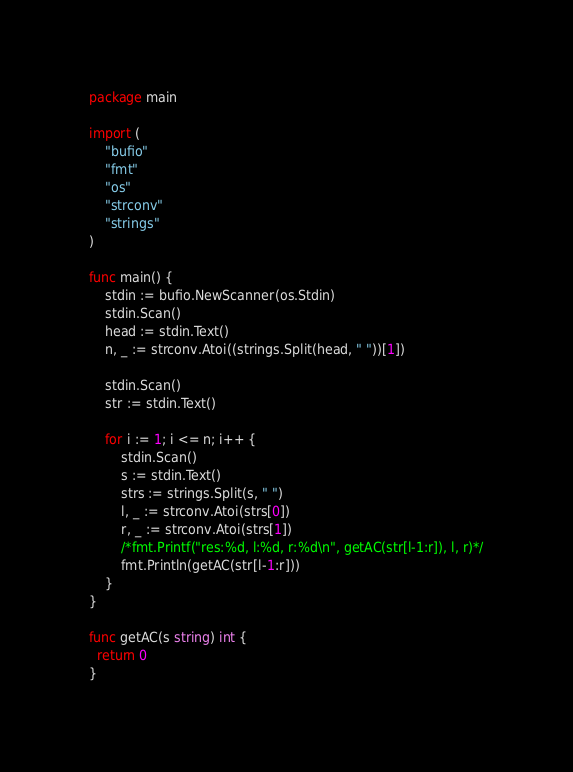<code> <loc_0><loc_0><loc_500><loc_500><_Go_>package main

import (
	"bufio"
	"fmt"
	"os"
	"strconv"
	"strings"
)

func main() {
	stdin := bufio.NewScanner(os.Stdin)
	stdin.Scan()
	head := stdin.Text()
	n, _ := strconv.Atoi((strings.Split(head, " "))[1])

	stdin.Scan()
	str := stdin.Text()

	for i := 1; i <= n; i++ {
		stdin.Scan()
		s := stdin.Text()
		strs := strings.Split(s, " ")
		l, _ := strconv.Atoi(strs[0])
		r, _ := strconv.Atoi(strs[1])
		/*fmt.Printf("res:%d, l:%d, r:%d\n", getAC(str[l-1:r]), l, r)*/
		fmt.Println(getAC(str[l-1:r]))
	}
}

func getAC(s string) int {
  return 0
}
</code> 